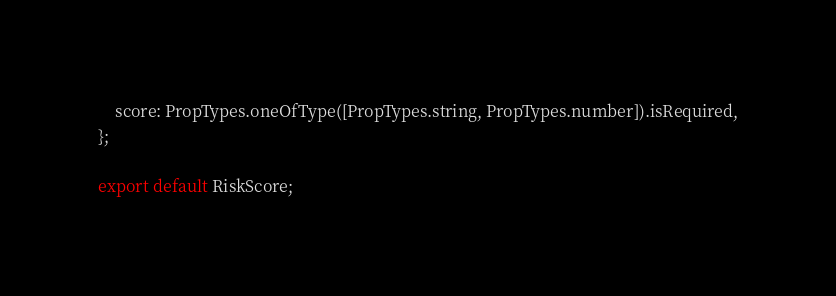Convert code to text. <code><loc_0><loc_0><loc_500><loc_500><_JavaScript_>    score: PropTypes.oneOfType([PropTypes.string, PropTypes.number]).isRequired,
};

export default RiskScore;
</code> 